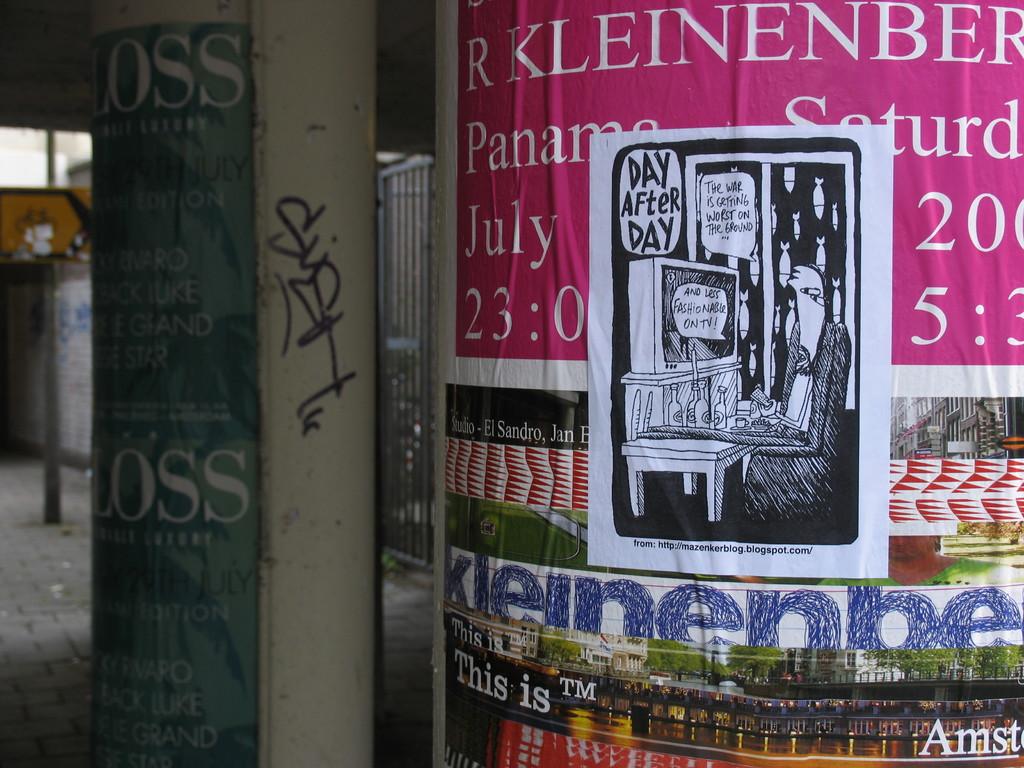When is the show on the pink poster?
Give a very brief answer. July 23. 